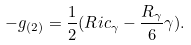Convert formula to latex. <formula><loc_0><loc_0><loc_500><loc_500>- g _ { ( 2 ) } = \frac { 1 } { 2 } ( R i c _ { \gamma } - \frac { R _ { \gamma } } { 6 } \gamma ) .</formula> 